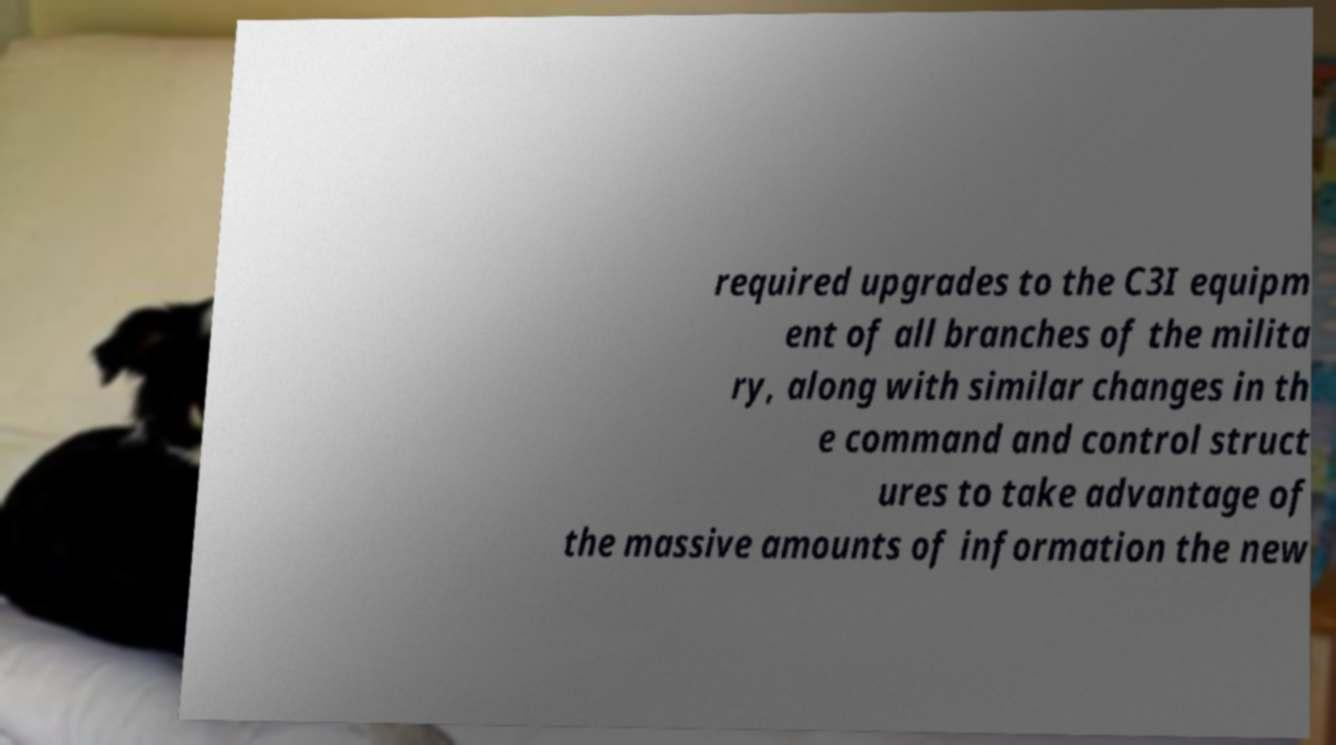Please read and relay the text visible in this image. What does it say? required upgrades to the C3I equipm ent of all branches of the milita ry, along with similar changes in th e command and control struct ures to take advantage of the massive amounts of information the new 